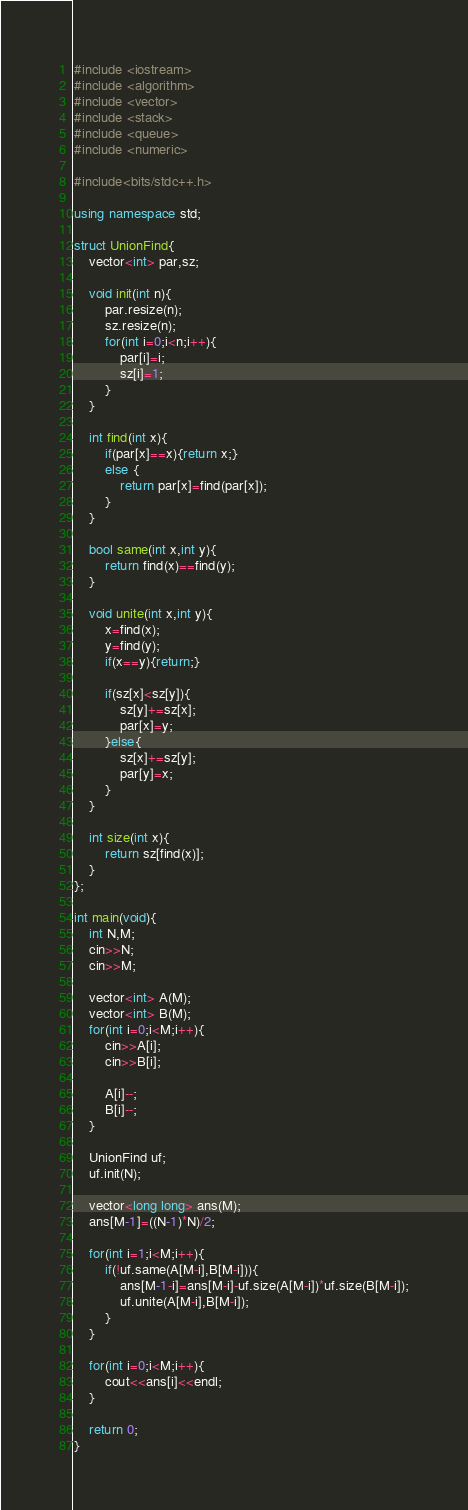<code> <loc_0><loc_0><loc_500><loc_500><_C++_>#include <iostream>
#include <algorithm>
#include <vector>
#include <stack>
#include <queue>
#include <numeric>

#include<bits/stdc++.h>

using namespace std;

struct UnionFind{
    vector<int> par,sz;

    void init(int n){
        par.resize(n);
        sz.resize(n);
        for(int i=0;i<n;i++){
            par[i]=i;
            sz[i]=1;
        }
    }

    int find(int x){
        if(par[x]==x){return x;}
        else {
            return par[x]=find(par[x]);
        }
    }

    bool same(int x,int y){
        return find(x)==find(y);
    }

    void unite(int x,int y){
        x=find(x);
        y=find(y);
        if(x==y){return;}

        if(sz[x]<sz[y]){
            sz[y]+=sz[x];
            par[x]=y;            
        }else{
            sz[x]+=sz[y];
            par[y]=x;
        }
    }

    int size(int x){
        return sz[find(x)];
    }
};

int main(void){
    int N,M;
    cin>>N;
    cin>>M;

    vector<int> A(M);
    vector<int> B(M);
    for(int i=0;i<M;i++){
        cin>>A[i];
        cin>>B[i];

        A[i]--;
        B[i]--;
    }

    UnionFind uf;
    uf.init(N);

    vector<long long> ans(M);
    ans[M-1]=((N-1)*N)/2;

    for(int i=1;i<M;i++){
        if(!uf.same(A[M-i],B[M-i])){
            ans[M-1-i]=ans[M-i]-uf.size(A[M-i])*uf.size(B[M-i]);
            uf.unite(A[M-i],B[M-i]);
        }
    }

    for(int i=0;i<M;i++){
        cout<<ans[i]<<endl;
    }

    return 0;
}</code> 